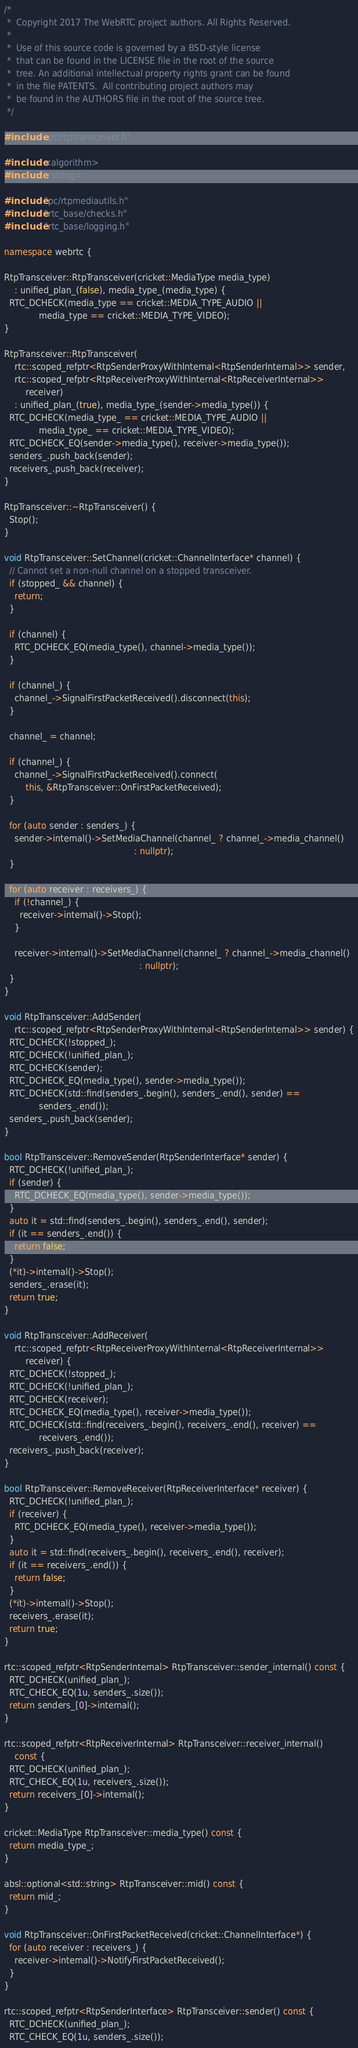Convert code to text. <code><loc_0><loc_0><loc_500><loc_500><_C++_>/*
 *  Copyright 2017 The WebRTC project authors. All Rights Reserved.
 *
 *  Use of this source code is governed by a BSD-style license
 *  that can be found in the LICENSE file in the root of the source
 *  tree. An additional intellectual property rights grant can be found
 *  in the file PATENTS.  All contributing project authors may
 *  be found in the AUTHORS file in the root of the source tree.
 */

#include "pc/rtptransceiver.h"

#include <algorithm>
#include <string>

#include "pc/rtpmediautils.h"
#include "rtc_base/checks.h"
#include "rtc_base/logging.h"

namespace webrtc {

RtpTransceiver::RtpTransceiver(cricket::MediaType media_type)
    : unified_plan_(false), media_type_(media_type) {
  RTC_DCHECK(media_type == cricket::MEDIA_TYPE_AUDIO ||
             media_type == cricket::MEDIA_TYPE_VIDEO);
}

RtpTransceiver::RtpTransceiver(
    rtc::scoped_refptr<RtpSenderProxyWithInternal<RtpSenderInternal>> sender,
    rtc::scoped_refptr<RtpReceiverProxyWithInternal<RtpReceiverInternal>>
        receiver)
    : unified_plan_(true), media_type_(sender->media_type()) {
  RTC_DCHECK(media_type_ == cricket::MEDIA_TYPE_AUDIO ||
             media_type_ == cricket::MEDIA_TYPE_VIDEO);
  RTC_DCHECK_EQ(sender->media_type(), receiver->media_type());
  senders_.push_back(sender);
  receivers_.push_back(receiver);
}

RtpTransceiver::~RtpTransceiver() {
  Stop();
}

void RtpTransceiver::SetChannel(cricket::ChannelInterface* channel) {
  // Cannot set a non-null channel on a stopped transceiver.
  if (stopped_ && channel) {
    return;
  }

  if (channel) {
    RTC_DCHECK_EQ(media_type(), channel->media_type());
  }

  if (channel_) {
    channel_->SignalFirstPacketReceived().disconnect(this);
  }

  channel_ = channel;

  if (channel_) {
    channel_->SignalFirstPacketReceived().connect(
        this, &RtpTransceiver::OnFirstPacketReceived);
  }

  for (auto sender : senders_) {
    sender->internal()->SetMediaChannel(channel_ ? channel_->media_channel()
                                                 : nullptr);
  }

  for (auto receiver : receivers_) {
    if (!channel_) {
      receiver->internal()->Stop();
    }

    receiver->internal()->SetMediaChannel(channel_ ? channel_->media_channel()
                                                   : nullptr);
  }
}

void RtpTransceiver::AddSender(
    rtc::scoped_refptr<RtpSenderProxyWithInternal<RtpSenderInternal>> sender) {
  RTC_DCHECK(!stopped_);
  RTC_DCHECK(!unified_plan_);
  RTC_DCHECK(sender);
  RTC_DCHECK_EQ(media_type(), sender->media_type());
  RTC_DCHECK(std::find(senders_.begin(), senders_.end(), sender) ==
             senders_.end());
  senders_.push_back(sender);
}

bool RtpTransceiver::RemoveSender(RtpSenderInterface* sender) {
  RTC_DCHECK(!unified_plan_);
  if (sender) {
    RTC_DCHECK_EQ(media_type(), sender->media_type());
  }
  auto it = std::find(senders_.begin(), senders_.end(), sender);
  if (it == senders_.end()) {
    return false;
  }
  (*it)->internal()->Stop();
  senders_.erase(it);
  return true;
}

void RtpTransceiver::AddReceiver(
    rtc::scoped_refptr<RtpReceiverProxyWithInternal<RtpReceiverInternal>>
        receiver) {
  RTC_DCHECK(!stopped_);
  RTC_DCHECK(!unified_plan_);
  RTC_DCHECK(receiver);
  RTC_DCHECK_EQ(media_type(), receiver->media_type());
  RTC_DCHECK(std::find(receivers_.begin(), receivers_.end(), receiver) ==
             receivers_.end());
  receivers_.push_back(receiver);
}

bool RtpTransceiver::RemoveReceiver(RtpReceiverInterface* receiver) {
  RTC_DCHECK(!unified_plan_);
  if (receiver) {
    RTC_DCHECK_EQ(media_type(), receiver->media_type());
  }
  auto it = std::find(receivers_.begin(), receivers_.end(), receiver);
  if (it == receivers_.end()) {
    return false;
  }
  (*it)->internal()->Stop();
  receivers_.erase(it);
  return true;
}

rtc::scoped_refptr<RtpSenderInternal> RtpTransceiver::sender_internal() const {
  RTC_DCHECK(unified_plan_);
  RTC_CHECK_EQ(1u, senders_.size());
  return senders_[0]->internal();
}

rtc::scoped_refptr<RtpReceiverInternal> RtpTransceiver::receiver_internal()
    const {
  RTC_DCHECK(unified_plan_);
  RTC_CHECK_EQ(1u, receivers_.size());
  return receivers_[0]->internal();
}

cricket::MediaType RtpTransceiver::media_type() const {
  return media_type_;
}

absl::optional<std::string> RtpTransceiver::mid() const {
  return mid_;
}

void RtpTransceiver::OnFirstPacketReceived(cricket::ChannelInterface*) {
  for (auto receiver : receivers_) {
    receiver->internal()->NotifyFirstPacketReceived();
  }
}

rtc::scoped_refptr<RtpSenderInterface> RtpTransceiver::sender() const {
  RTC_DCHECK(unified_plan_);
  RTC_CHECK_EQ(1u, senders_.size());</code> 